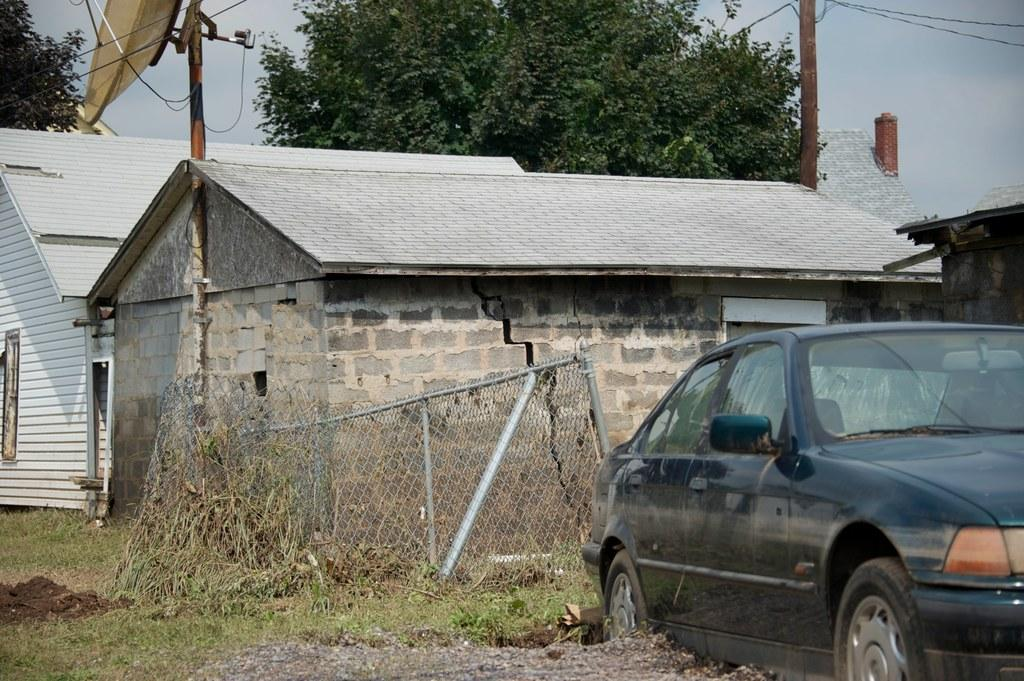What can be seen in the foreground of the picture? In the foreground of the picture, there are plants, grass, a car, a railing, and buildings. What is located in the center of the picture? In the center of the picture, there are trees, houses, a current pole, an antenna, and cables. How many feet are visible in the picture? There are no feet visible in the picture. What type of show is being performed in the center of the picture? There is no show being performed in the picture; it features a variety of objects and structures. 